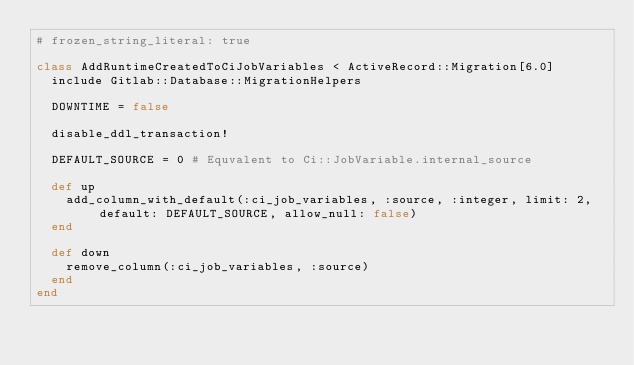<code> <loc_0><loc_0><loc_500><loc_500><_Ruby_># frozen_string_literal: true

class AddRuntimeCreatedToCiJobVariables < ActiveRecord::Migration[6.0]
  include Gitlab::Database::MigrationHelpers

  DOWNTIME = false

  disable_ddl_transaction!

  DEFAULT_SOURCE = 0 # Equvalent to Ci::JobVariable.internal_source

  def up
    add_column_with_default(:ci_job_variables, :source, :integer, limit: 2, default: DEFAULT_SOURCE, allow_null: false)
  end

  def down
    remove_column(:ci_job_variables, :source)
  end
end
</code> 